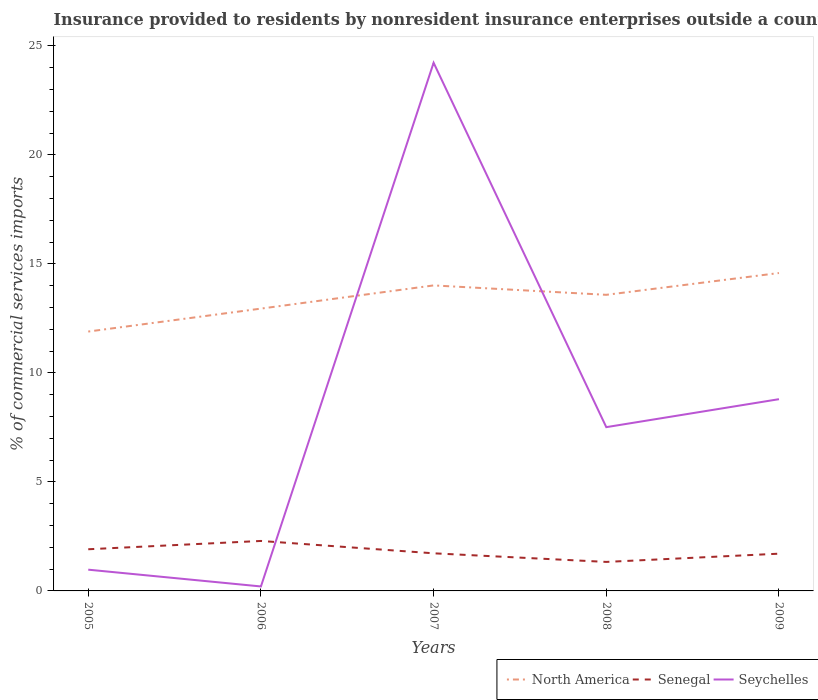How many different coloured lines are there?
Make the answer very short. 3. Does the line corresponding to Seychelles intersect with the line corresponding to Senegal?
Keep it short and to the point. Yes. Is the number of lines equal to the number of legend labels?
Give a very brief answer. Yes. Across all years, what is the maximum Insurance provided to residents in Seychelles?
Your answer should be compact. 0.2. In which year was the Insurance provided to residents in North America maximum?
Offer a very short reply. 2005. What is the total Insurance provided to residents in North America in the graph?
Give a very brief answer. -1. What is the difference between the highest and the second highest Insurance provided to residents in North America?
Your response must be concise. 2.69. Is the Insurance provided to residents in Senegal strictly greater than the Insurance provided to residents in Seychelles over the years?
Your response must be concise. No. How many years are there in the graph?
Your answer should be very brief. 5. What is the difference between two consecutive major ticks on the Y-axis?
Provide a succinct answer. 5. Does the graph contain grids?
Your response must be concise. No. Where does the legend appear in the graph?
Offer a terse response. Bottom right. What is the title of the graph?
Ensure brevity in your answer.  Insurance provided to residents by nonresident insurance enterprises outside a country. Does "Italy" appear as one of the legend labels in the graph?
Your answer should be compact. No. What is the label or title of the X-axis?
Offer a very short reply. Years. What is the label or title of the Y-axis?
Your response must be concise. % of commercial services imports. What is the % of commercial services imports in North America in 2005?
Provide a succinct answer. 11.9. What is the % of commercial services imports of Senegal in 2005?
Ensure brevity in your answer.  1.91. What is the % of commercial services imports of Seychelles in 2005?
Ensure brevity in your answer.  0.97. What is the % of commercial services imports of North America in 2006?
Offer a very short reply. 12.95. What is the % of commercial services imports of Senegal in 2006?
Your answer should be compact. 2.29. What is the % of commercial services imports of Seychelles in 2006?
Provide a succinct answer. 0.2. What is the % of commercial services imports in North America in 2007?
Your response must be concise. 14.01. What is the % of commercial services imports of Senegal in 2007?
Ensure brevity in your answer.  1.73. What is the % of commercial services imports of Seychelles in 2007?
Your answer should be compact. 24.23. What is the % of commercial services imports in North America in 2008?
Offer a terse response. 13.58. What is the % of commercial services imports of Senegal in 2008?
Make the answer very short. 1.33. What is the % of commercial services imports of Seychelles in 2008?
Ensure brevity in your answer.  7.51. What is the % of commercial services imports of North America in 2009?
Your answer should be very brief. 14.58. What is the % of commercial services imports of Senegal in 2009?
Your response must be concise. 1.71. What is the % of commercial services imports in Seychelles in 2009?
Offer a terse response. 8.8. Across all years, what is the maximum % of commercial services imports of North America?
Your answer should be very brief. 14.58. Across all years, what is the maximum % of commercial services imports of Senegal?
Your answer should be compact. 2.29. Across all years, what is the maximum % of commercial services imports in Seychelles?
Offer a terse response. 24.23. Across all years, what is the minimum % of commercial services imports of North America?
Provide a succinct answer. 11.9. Across all years, what is the minimum % of commercial services imports of Senegal?
Ensure brevity in your answer.  1.33. Across all years, what is the minimum % of commercial services imports of Seychelles?
Make the answer very short. 0.2. What is the total % of commercial services imports in North America in the graph?
Ensure brevity in your answer.  67.03. What is the total % of commercial services imports in Senegal in the graph?
Provide a short and direct response. 8.97. What is the total % of commercial services imports in Seychelles in the graph?
Ensure brevity in your answer.  41.71. What is the difference between the % of commercial services imports of North America in 2005 and that in 2006?
Provide a short and direct response. -1.05. What is the difference between the % of commercial services imports in Senegal in 2005 and that in 2006?
Your answer should be compact. -0.38. What is the difference between the % of commercial services imports of Seychelles in 2005 and that in 2006?
Offer a terse response. 0.77. What is the difference between the % of commercial services imports in North America in 2005 and that in 2007?
Ensure brevity in your answer.  -2.12. What is the difference between the % of commercial services imports in Senegal in 2005 and that in 2007?
Your answer should be compact. 0.19. What is the difference between the % of commercial services imports in Seychelles in 2005 and that in 2007?
Provide a succinct answer. -23.25. What is the difference between the % of commercial services imports in North America in 2005 and that in 2008?
Offer a terse response. -1.68. What is the difference between the % of commercial services imports in Senegal in 2005 and that in 2008?
Your response must be concise. 0.58. What is the difference between the % of commercial services imports in Seychelles in 2005 and that in 2008?
Provide a short and direct response. -6.54. What is the difference between the % of commercial services imports in North America in 2005 and that in 2009?
Provide a short and direct response. -2.69. What is the difference between the % of commercial services imports of Senegal in 2005 and that in 2009?
Ensure brevity in your answer.  0.2. What is the difference between the % of commercial services imports in Seychelles in 2005 and that in 2009?
Keep it short and to the point. -7.82. What is the difference between the % of commercial services imports of North America in 2006 and that in 2007?
Ensure brevity in your answer.  -1.06. What is the difference between the % of commercial services imports in Senegal in 2006 and that in 2007?
Your answer should be very brief. 0.57. What is the difference between the % of commercial services imports of Seychelles in 2006 and that in 2007?
Your answer should be compact. -24.02. What is the difference between the % of commercial services imports of North America in 2006 and that in 2008?
Your response must be concise. -0.63. What is the difference between the % of commercial services imports in Senegal in 2006 and that in 2008?
Make the answer very short. 0.96. What is the difference between the % of commercial services imports in Seychelles in 2006 and that in 2008?
Your response must be concise. -7.31. What is the difference between the % of commercial services imports in North America in 2006 and that in 2009?
Your answer should be compact. -1.63. What is the difference between the % of commercial services imports in Senegal in 2006 and that in 2009?
Make the answer very short. 0.58. What is the difference between the % of commercial services imports in Seychelles in 2006 and that in 2009?
Offer a very short reply. -8.59. What is the difference between the % of commercial services imports of North America in 2007 and that in 2008?
Keep it short and to the point. 0.43. What is the difference between the % of commercial services imports in Senegal in 2007 and that in 2008?
Make the answer very short. 0.39. What is the difference between the % of commercial services imports in Seychelles in 2007 and that in 2008?
Keep it short and to the point. 16.71. What is the difference between the % of commercial services imports in North America in 2007 and that in 2009?
Your answer should be very brief. -0.57. What is the difference between the % of commercial services imports in Senegal in 2007 and that in 2009?
Make the answer very short. 0.02. What is the difference between the % of commercial services imports in Seychelles in 2007 and that in 2009?
Make the answer very short. 15.43. What is the difference between the % of commercial services imports in North America in 2008 and that in 2009?
Keep it short and to the point. -1. What is the difference between the % of commercial services imports of Senegal in 2008 and that in 2009?
Offer a very short reply. -0.38. What is the difference between the % of commercial services imports of Seychelles in 2008 and that in 2009?
Offer a terse response. -1.28. What is the difference between the % of commercial services imports in North America in 2005 and the % of commercial services imports in Senegal in 2006?
Offer a terse response. 9.61. What is the difference between the % of commercial services imports of North America in 2005 and the % of commercial services imports of Seychelles in 2006?
Your answer should be compact. 11.69. What is the difference between the % of commercial services imports in Senegal in 2005 and the % of commercial services imports in Seychelles in 2006?
Offer a very short reply. 1.71. What is the difference between the % of commercial services imports in North America in 2005 and the % of commercial services imports in Senegal in 2007?
Make the answer very short. 10.17. What is the difference between the % of commercial services imports in North America in 2005 and the % of commercial services imports in Seychelles in 2007?
Ensure brevity in your answer.  -12.33. What is the difference between the % of commercial services imports of Senegal in 2005 and the % of commercial services imports of Seychelles in 2007?
Keep it short and to the point. -22.32. What is the difference between the % of commercial services imports of North America in 2005 and the % of commercial services imports of Senegal in 2008?
Ensure brevity in your answer.  10.57. What is the difference between the % of commercial services imports in North America in 2005 and the % of commercial services imports in Seychelles in 2008?
Make the answer very short. 4.39. What is the difference between the % of commercial services imports of Senegal in 2005 and the % of commercial services imports of Seychelles in 2008?
Provide a succinct answer. -5.6. What is the difference between the % of commercial services imports in North America in 2005 and the % of commercial services imports in Senegal in 2009?
Provide a short and direct response. 10.19. What is the difference between the % of commercial services imports of North America in 2005 and the % of commercial services imports of Seychelles in 2009?
Your response must be concise. 3.1. What is the difference between the % of commercial services imports in Senegal in 2005 and the % of commercial services imports in Seychelles in 2009?
Offer a terse response. -6.88. What is the difference between the % of commercial services imports in North America in 2006 and the % of commercial services imports in Senegal in 2007?
Ensure brevity in your answer.  11.22. What is the difference between the % of commercial services imports of North America in 2006 and the % of commercial services imports of Seychelles in 2007?
Keep it short and to the point. -11.28. What is the difference between the % of commercial services imports of Senegal in 2006 and the % of commercial services imports of Seychelles in 2007?
Your response must be concise. -21.93. What is the difference between the % of commercial services imports of North America in 2006 and the % of commercial services imports of Senegal in 2008?
Your answer should be compact. 11.62. What is the difference between the % of commercial services imports of North America in 2006 and the % of commercial services imports of Seychelles in 2008?
Ensure brevity in your answer.  5.44. What is the difference between the % of commercial services imports in Senegal in 2006 and the % of commercial services imports in Seychelles in 2008?
Keep it short and to the point. -5.22. What is the difference between the % of commercial services imports in North America in 2006 and the % of commercial services imports in Senegal in 2009?
Provide a short and direct response. 11.24. What is the difference between the % of commercial services imports of North America in 2006 and the % of commercial services imports of Seychelles in 2009?
Provide a short and direct response. 4.15. What is the difference between the % of commercial services imports of Senegal in 2006 and the % of commercial services imports of Seychelles in 2009?
Give a very brief answer. -6.5. What is the difference between the % of commercial services imports of North America in 2007 and the % of commercial services imports of Senegal in 2008?
Offer a terse response. 12.68. What is the difference between the % of commercial services imports of North America in 2007 and the % of commercial services imports of Seychelles in 2008?
Give a very brief answer. 6.5. What is the difference between the % of commercial services imports of Senegal in 2007 and the % of commercial services imports of Seychelles in 2008?
Offer a terse response. -5.79. What is the difference between the % of commercial services imports in North America in 2007 and the % of commercial services imports in Senegal in 2009?
Provide a succinct answer. 12.31. What is the difference between the % of commercial services imports of North America in 2007 and the % of commercial services imports of Seychelles in 2009?
Your answer should be very brief. 5.22. What is the difference between the % of commercial services imports in Senegal in 2007 and the % of commercial services imports in Seychelles in 2009?
Your answer should be compact. -7.07. What is the difference between the % of commercial services imports of North America in 2008 and the % of commercial services imports of Senegal in 2009?
Keep it short and to the point. 11.87. What is the difference between the % of commercial services imports in North America in 2008 and the % of commercial services imports in Seychelles in 2009?
Ensure brevity in your answer.  4.79. What is the difference between the % of commercial services imports in Senegal in 2008 and the % of commercial services imports in Seychelles in 2009?
Ensure brevity in your answer.  -7.46. What is the average % of commercial services imports in North America per year?
Give a very brief answer. 13.41. What is the average % of commercial services imports of Senegal per year?
Provide a short and direct response. 1.79. What is the average % of commercial services imports in Seychelles per year?
Your answer should be very brief. 8.34. In the year 2005, what is the difference between the % of commercial services imports of North America and % of commercial services imports of Senegal?
Provide a short and direct response. 9.99. In the year 2005, what is the difference between the % of commercial services imports in North America and % of commercial services imports in Seychelles?
Your response must be concise. 10.92. In the year 2005, what is the difference between the % of commercial services imports in Senegal and % of commercial services imports in Seychelles?
Provide a succinct answer. 0.94. In the year 2006, what is the difference between the % of commercial services imports in North America and % of commercial services imports in Senegal?
Your answer should be very brief. 10.66. In the year 2006, what is the difference between the % of commercial services imports of North America and % of commercial services imports of Seychelles?
Offer a very short reply. 12.75. In the year 2006, what is the difference between the % of commercial services imports in Senegal and % of commercial services imports in Seychelles?
Your response must be concise. 2.09. In the year 2007, what is the difference between the % of commercial services imports in North America and % of commercial services imports in Senegal?
Give a very brief answer. 12.29. In the year 2007, what is the difference between the % of commercial services imports of North America and % of commercial services imports of Seychelles?
Keep it short and to the point. -10.21. In the year 2007, what is the difference between the % of commercial services imports of Senegal and % of commercial services imports of Seychelles?
Offer a terse response. -22.5. In the year 2008, what is the difference between the % of commercial services imports of North America and % of commercial services imports of Senegal?
Ensure brevity in your answer.  12.25. In the year 2008, what is the difference between the % of commercial services imports in North America and % of commercial services imports in Seychelles?
Your answer should be compact. 6.07. In the year 2008, what is the difference between the % of commercial services imports of Senegal and % of commercial services imports of Seychelles?
Provide a succinct answer. -6.18. In the year 2009, what is the difference between the % of commercial services imports of North America and % of commercial services imports of Senegal?
Offer a terse response. 12.87. In the year 2009, what is the difference between the % of commercial services imports in North America and % of commercial services imports in Seychelles?
Your answer should be very brief. 5.79. In the year 2009, what is the difference between the % of commercial services imports of Senegal and % of commercial services imports of Seychelles?
Your answer should be very brief. -7.09. What is the ratio of the % of commercial services imports in North America in 2005 to that in 2006?
Your answer should be compact. 0.92. What is the ratio of the % of commercial services imports in Senegal in 2005 to that in 2006?
Provide a short and direct response. 0.83. What is the ratio of the % of commercial services imports of Seychelles in 2005 to that in 2006?
Offer a very short reply. 4.76. What is the ratio of the % of commercial services imports in North America in 2005 to that in 2007?
Your answer should be very brief. 0.85. What is the ratio of the % of commercial services imports of Senegal in 2005 to that in 2007?
Make the answer very short. 1.11. What is the ratio of the % of commercial services imports in Seychelles in 2005 to that in 2007?
Make the answer very short. 0.04. What is the ratio of the % of commercial services imports of North America in 2005 to that in 2008?
Ensure brevity in your answer.  0.88. What is the ratio of the % of commercial services imports in Senegal in 2005 to that in 2008?
Offer a very short reply. 1.44. What is the ratio of the % of commercial services imports in Seychelles in 2005 to that in 2008?
Your response must be concise. 0.13. What is the ratio of the % of commercial services imports of North America in 2005 to that in 2009?
Keep it short and to the point. 0.82. What is the ratio of the % of commercial services imports in Senegal in 2005 to that in 2009?
Your answer should be compact. 1.12. What is the ratio of the % of commercial services imports in Seychelles in 2005 to that in 2009?
Provide a succinct answer. 0.11. What is the ratio of the % of commercial services imports of North America in 2006 to that in 2007?
Ensure brevity in your answer.  0.92. What is the ratio of the % of commercial services imports in Senegal in 2006 to that in 2007?
Provide a succinct answer. 1.33. What is the ratio of the % of commercial services imports of Seychelles in 2006 to that in 2007?
Offer a terse response. 0.01. What is the ratio of the % of commercial services imports in North America in 2006 to that in 2008?
Your answer should be compact. 0.95. What is the ratio of the % of commercial services imports in Senegal in 2006 to that in 2008?
Keep it short and to the point. 1.72. What is the ratio of the % of commercial services imports of Seychelles in 2006 to that in 2008?
Offer a terse response. 0.03. What is the ratio of the % of commercial services imports of North America in 2006 to that in 2009?
Provide a succinct answer. 0.89. What is the ratio of the % of commercial services imports in Senegal in 2006 to that in 2009?
Provide a short and direct response. 1.34. What is the ratio of the % of commercial services imports of Seychelles in 2006 to that in 2009?
Keep it short and to the point. 0.02. What is the ratio of the % of commercial services imports of North America in 2007 to that in 2008?
Give a very brief answer. 1.03. What is the ratio of the % of commercial services imports in Senegal in 2007 to that in 2008?
Make the answer very short. 1.3. What is the ratio of the % of commercial services imports of Seychelles in 2007 to that in 2008?
Give a very brief answer. 3.23. What is the ratio of the % of commercial services imports of North America in 2007 to that in 2009?
Keep it short and to the point. 0.96. What is the ratio of the % of commercial services imports of Senegal in 2007 to that in 2009?
Provide a succinct answer. 1.01. What is the ratio of the % of commercial services imports in Seychelles in 2007 to that in 2009?
Keep it short and to the point. 2.75. What is the ratio of the % of commercial services imports in North America in 2008 to that in 2009?
Your answer should be compact. 0.93. What is the ratio of the % of commercial services imports of Senegal in 2008 to that in 2009?
Make the answer very short. 0.78. What is the ratio of the % of commercial services imports in Seychelles in 2008 to that in 2009?
Offer a terse response. 0.85. What is the difference between the highest and the second highest % of commercial services imports of North America?
Offer a terse response. 0.57. What is the difference between the highest and the second highest % of commercial services imports of Senegal?
Provide a short and direct response. 0.38. What is the difference between the highest and the second highest % of commercial services imports of Seychelles?
Ensure brevity in your answer.  15.43. What is the difference between the highest and the lowest % of commercial services imports in North America?
Your answer should be compact. 2.69. What is the difference between the highest and the lowest % of commercial services imports in Senegal?
Keep it short and to the point. 0.96. What is the difference between the highest and the lowest % of commercial services imports in Seychelles?
Provide a succinct answer. 24.02. 